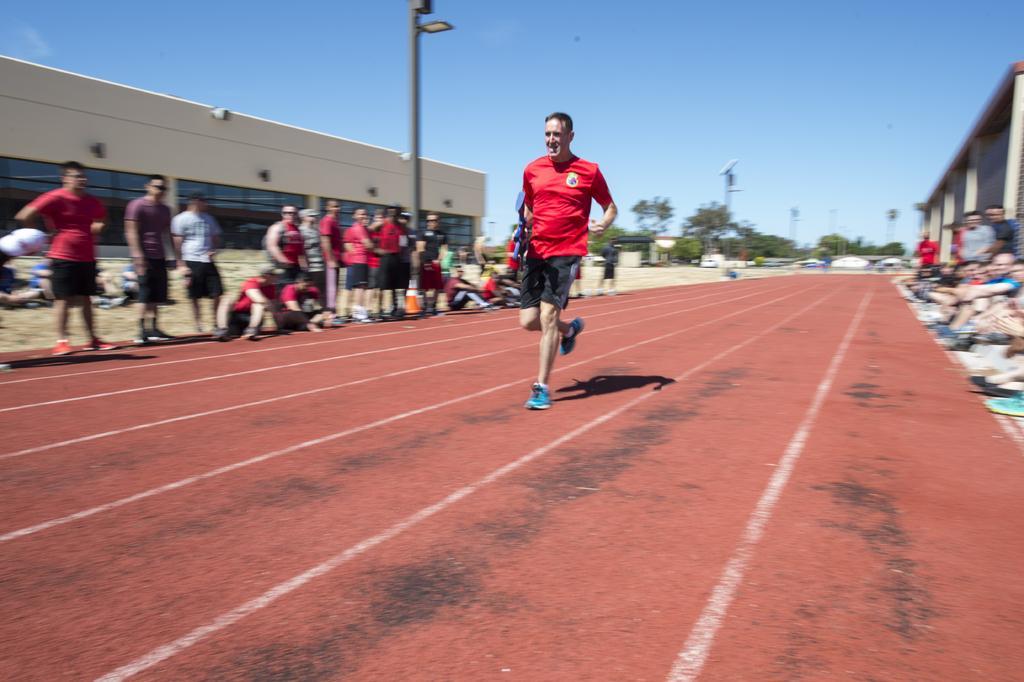Could you give a brief overview of what you see in this image? In this image we can see a man running on the ground and some are sitting and standing on the ground. In the background there are buildings, street poles, street lights, trees and sky. 